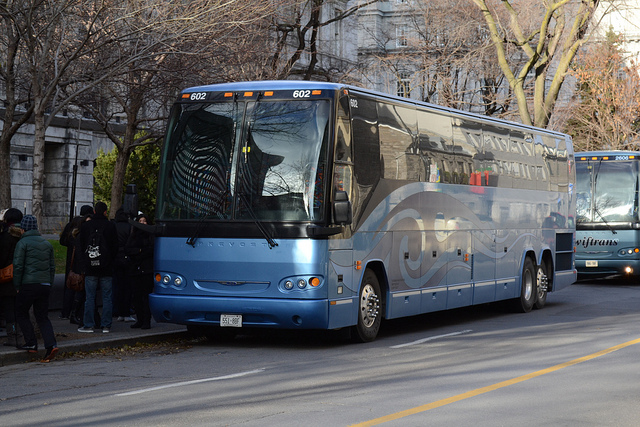Can you tell me about the make and model of the bus? The bus in the image is a Prevost, recognizable by its characteristic design and logo on the front and side. Prevost is a Québec-based company known for manufacturing high-quality motorcoaches and transit buses.  Do the reflection and surroundings suggest anything about the location or time of day? The reflection on the bus shows leafless trees, indicating it may be autumn or winter. The shadows are long, suggesting this photo was taken either in the early morning or late afternoon. The architecture reflected in the windows seems urban, hinting that this bus is within a city. 